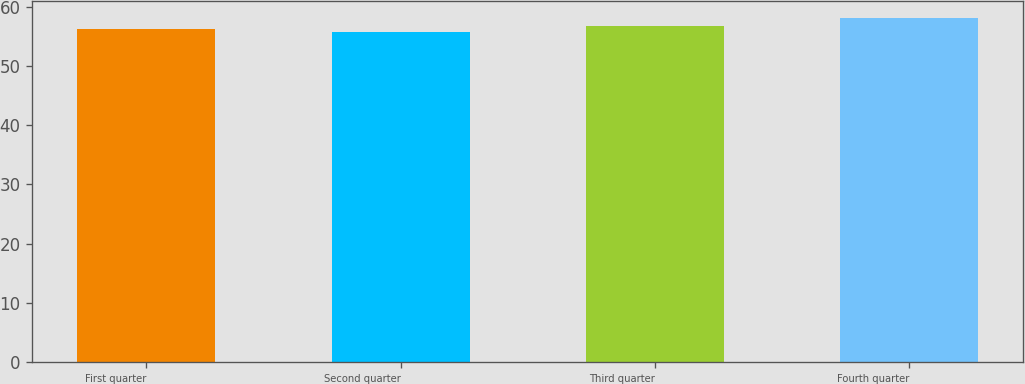Convert chart to OTSL. <chart><loc_0><loc_0><loc_500><loc_500><bar_chart><fcel>First quarter<fcel>Second quarter<fcel>Third quarter<fcel>Fourth quarter<nl><fcel>56.23<fcel>55.73<fcel>56.68<fcel>58.07<nl></chart> 